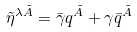<formula> <loc_0><loc_0><loc_500><loc_500>\tilde { \eta } ^ { \lambda \tilde { A } } = \bar { \gamma } q ^ { \tilde { A } } + \gamma \bar { q } ^ { \tilde { A } }</formula> 